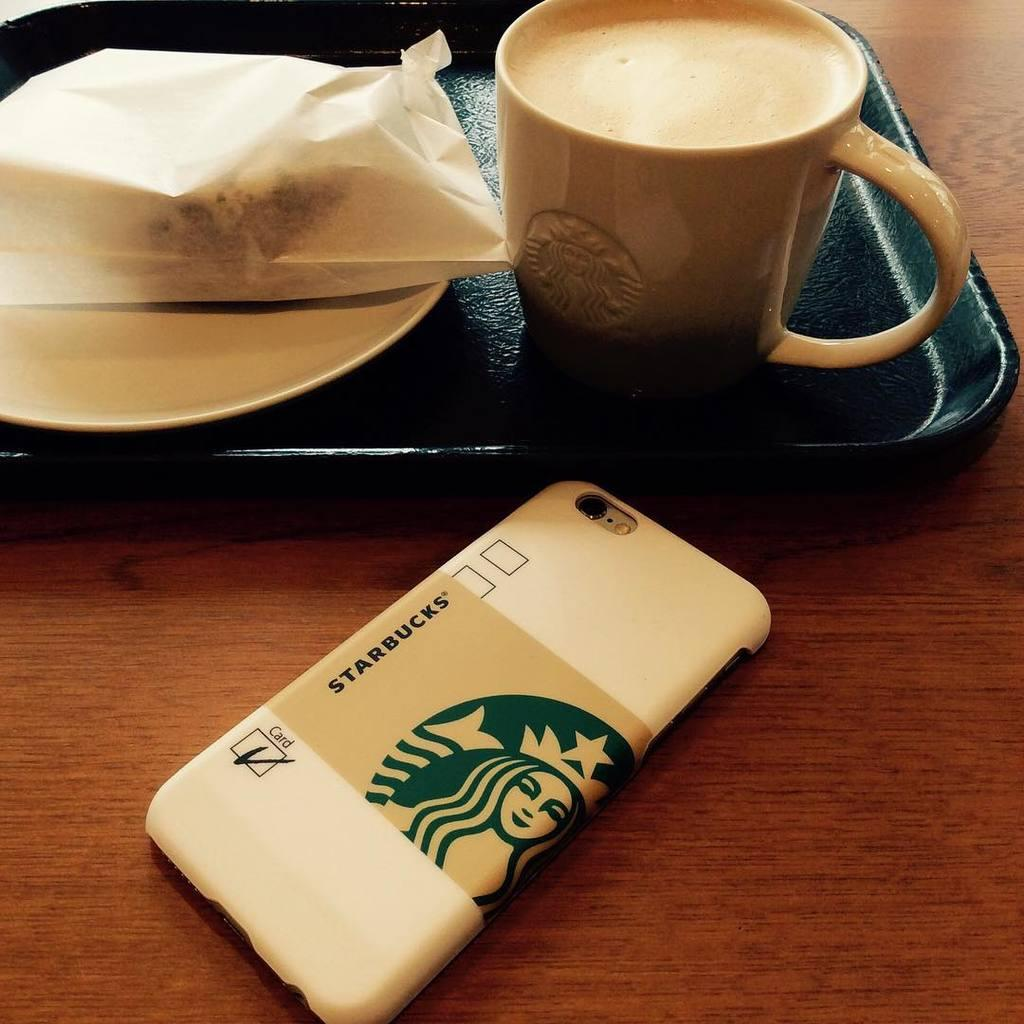<image>
Describe the image concisely. the Starbucks coffee in a black tray  placed near to Starbucks symbol and letters printed back of the phone 